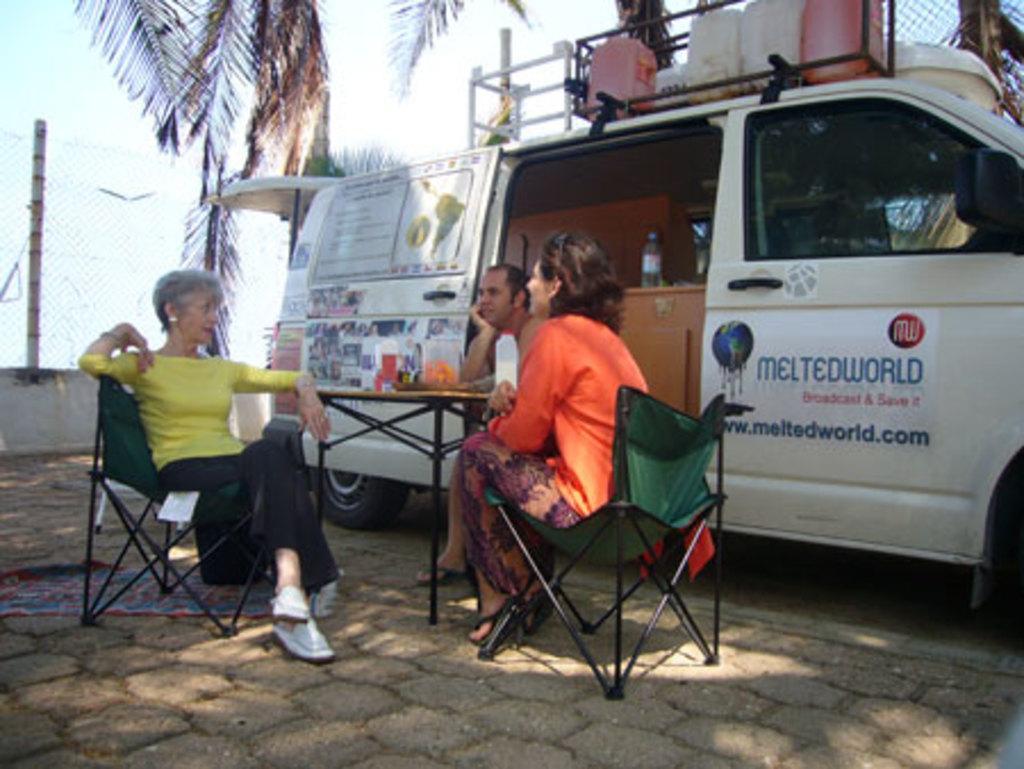Describe this image in one or two sentences. Completely an outdoor picture. These three persons are sitting on a chair. In-front of this person there is a table, on a table there is a box and jar. Beside this person there is a vehicle, on top of this vehicle's there are cans. We can able to see a tree. 